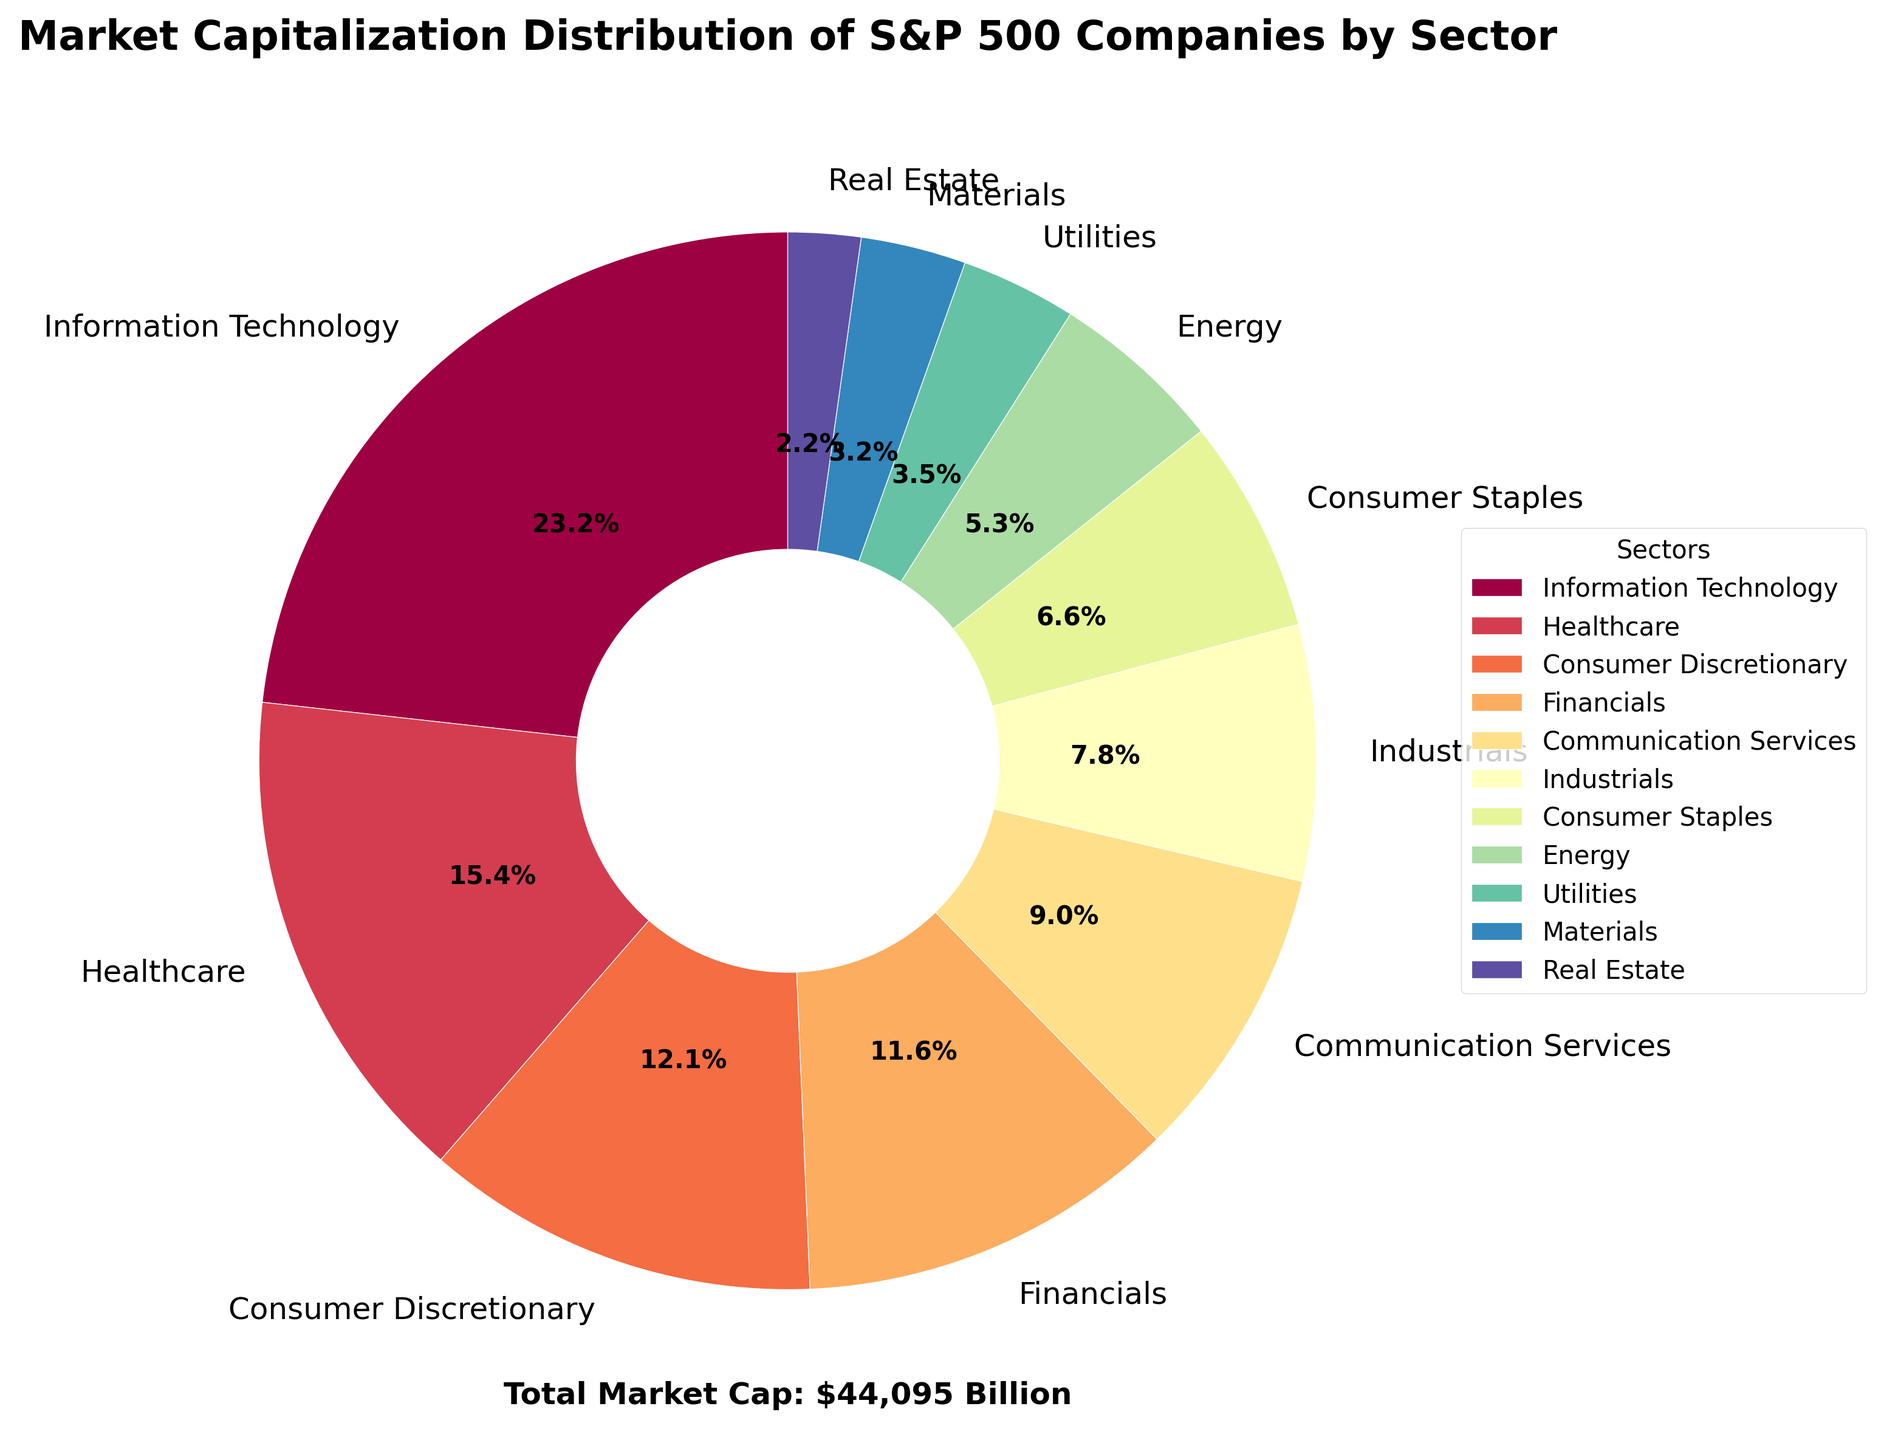What's the sector with the highest market capitalization? Look at the labels on the pie chart and identify which sector occupies the largest wedge. "Information Technology" sector has the largest portion with a market cap of $10,245 billion.
Answer: Information Technology Which two sectors together make up more than 50% of the total market capitalization? First, identify the sectors with the largest market caps: Information Technology and Healthcare. Add their market caps: 10,245 billion + 6,780 billion = 17,025 billion. Check if 17,025 is more than half of the total market cap, which is 57,095 billion. 17,025 > 50% * 57,095.
Answer: Information Technology and Healthcare What's the difference in market capitalization between Financials and Real Estate? Find the market caps of Financials and Real Estate from the pie chart: 5,130 billion and 980 billion, respectively. Subtract the smaller value from the larger value: 5,130 - 980 = 4,150 billion USD.
Answer: 4,150 billion USD Which sector occupies the smallest wedge? Observe the wedges in the pie chart and identify the smallest one. The sector "Real Estate" has the smallest market cap with 980 billion USD.
Answer: Real Estate What is the combined market capitalization of the Consumer sectors (Consumer Discretionary and Consumer Staples)? Look at the wedges for Consumer Discretionary and Consumer Staples. Their market caps are 5,320 billion and 2,890 billion, respectively. Add these values: 5,320 billion + 2,890 billion = 8,210 billion USD.
Answer: 8,210 billion USD How much larger is the market cap of the Information Technology sector compared to the Utilities sector? Find the market caps of Information Technology and Utilities: 10,245 billion and 1,560 billion, respectively. Subtract the smaller value from the larger value: 10,245 - 1,560 = 8,685 billion USD.
Answer: 8,685 billion USD Which sector has the closest market cap to Utilities? Identify the market cap for Utilities (1,560 billion USD) and compare it to nearby values: Materials (1,420 billion USD). The difference is smallest for Materials.
Answer: Materials What percentage of the total market cap is held by the Energy sector? Identify the market cap for Energy from the pie chart: 2,340 billion USD. Calculate the percentage: (2,340 / 57,095) * 100 ≈ 4.1%.
Answer: 4.1% Is the sum of market caps for the Industrials and Consumer Staples sectors greater than the Financials sector? Add the market caps for Industrials and Consumer Staples: 3,450 billion + 2,890 billion = 6,340 billion USD. Compare it to Financials: 6,340 billion > 5,130 billion.
Answer: Yes What is the visual distinguishing feature of the Communication Services sector? Observe the color spectrum used in the pie chart. Communication Services is represented by a visually distinct wedge with a specific color that stands out compared to other sectors. Mention the light yellow color used for it.
Answer: Light yellow color 